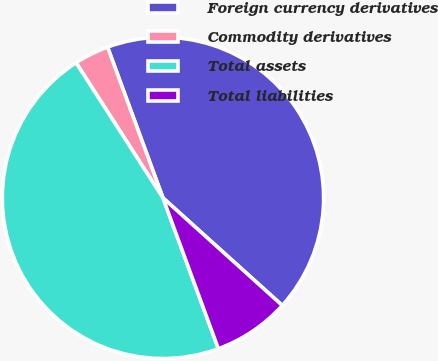<chart> <loc_0><loc_0><loc_500><loc_500><pie_chart><fcel>Foreign currency derivatives<fcel>Commodity derivatives<fcel>Total assets<fcel>Total liabilities<nl><fcel>42.28%<fcel>3.49%<fcel>46.51%<fcel>7.72%<nl></chart> 